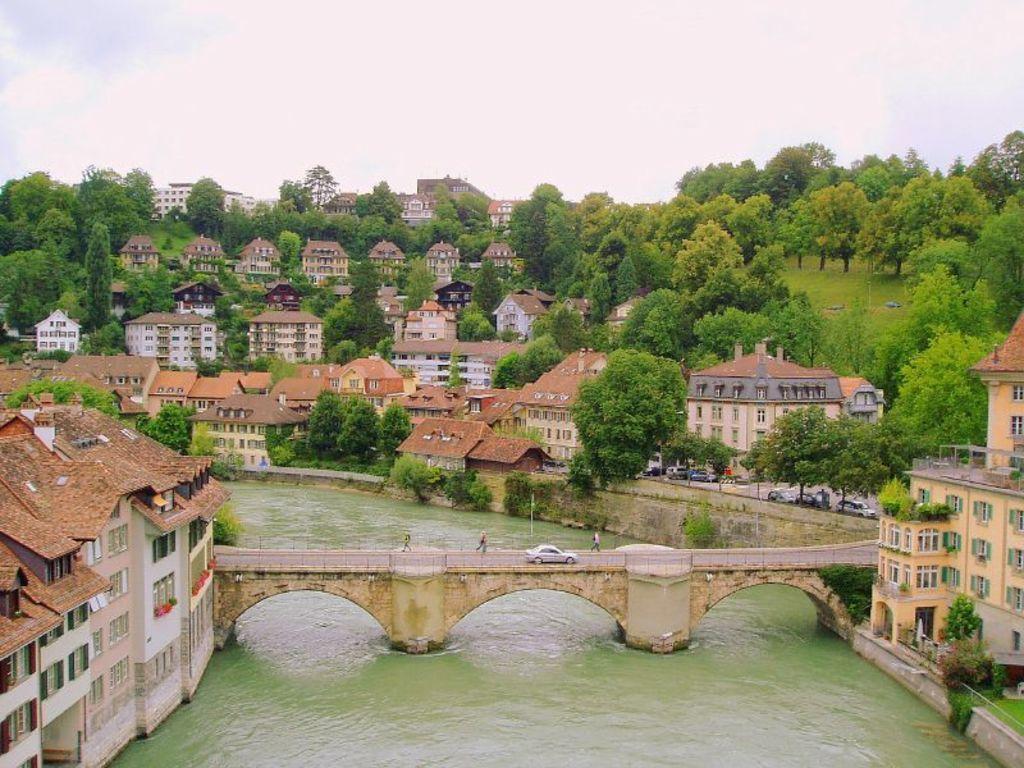Describe this image in one or two sentences. This image consists of buildings. There is a bridge in the center and on the bridge there are persons and there is a car. In the background there are trees and the sky is cloudy. 